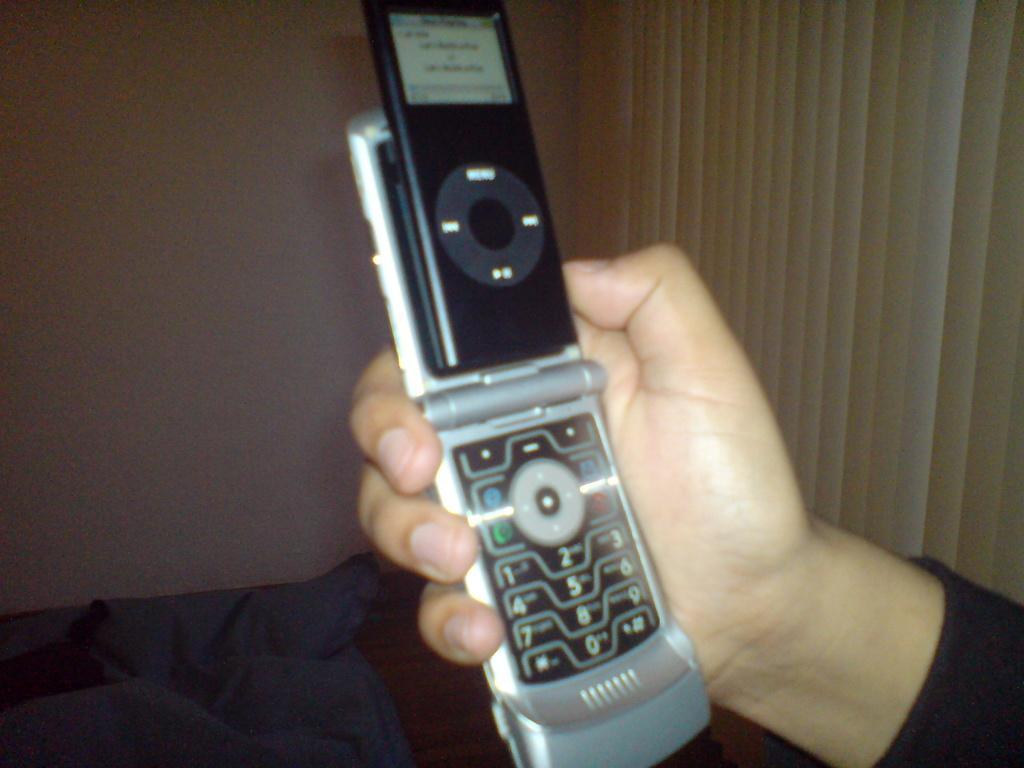In one or two sentences, can you explain what this image depicts? In this image we can see there is a person's hand and he is holding a mobile. In the background there is a wall. 